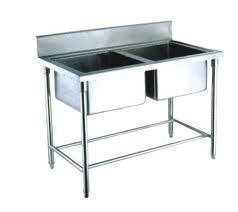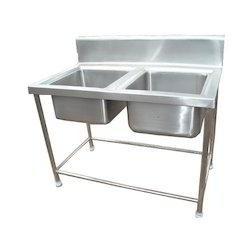The first image is the image on the left, the second image is the image on the right. Analyze the images presented: Is the assertion "There is a double sink with a slotted storage rack under it" valid? Answer yes or no. No. The first image is the image on the left, the second image is the image on the right. Given the left and right images, does the statement "Design features present in the combined images include a railed lower shelf, and extra open space on the right of two stainless steel sinks in one unit." hold true? Answer yes or no. No. 